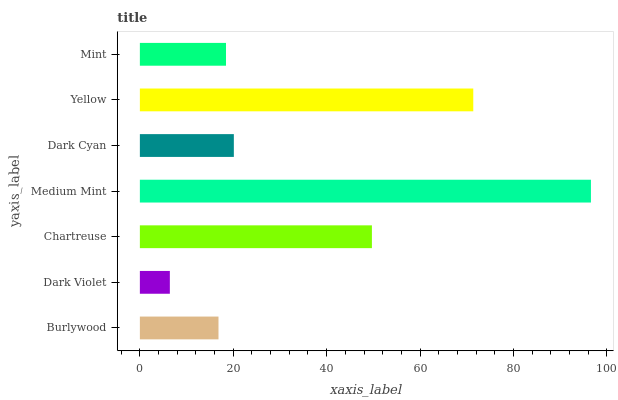Is Dark Violet the minimum?
Answer yes or no. Yes. Is Medium Mint the maximum?
Answer yes or no. Yes. Is Chartreuse the minimum?
Answer yes or no. No. Is Chartreuse the maximum?
Answer yes or no. No. Is Chartreuse greater than Dark Violet?
Answer yes or no. Yes. Is Dark Violet less than Chartreuse?
Answer yes or no. Yes. Is Dark Violet greater than Chartreuse?
Answer yes or no. No. Is Chartreuse less than Dark Violet?
Answer yes or no. No. Is Dark Cyan the high median?
Answer yes or no. Yes. Is Dark Cyan the low median?
Answer yes or no. Yes. Is Mint the high median?
Answer yes or no. No. Is Medium Mint the low median?
Answer yes or no. No. 